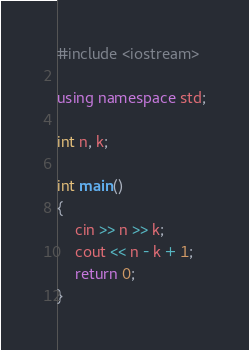<code> <loc_0><loc_0><loc_500><loc_500><_C++_>#include <iostream>

using namespace std;

int n, k;

int main()
{
    cin >> n >> k;
  	cout << n - k + 1;
    return 0;
}
</code> 